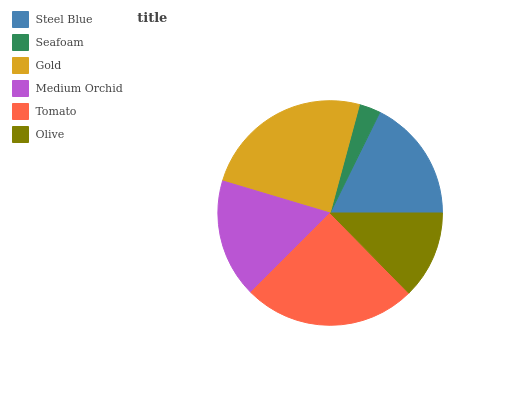Is Seafoam the minimum?
Answer yes or no. Yes. Is Tomato the maximum?
Answer yes or no. Yes. Is Gold the minimum?
Answer yes or no. No. Is Gold the maximum?
Answer yes or no. No. Is Gold greater than Seafoam?
Answer yes or no. Yes. Is Seafoam less than Gold?
Answer yes or no. Yes. Is Seafoam greater than Gold?
Answer yes or no. No. Is Gold less than Seafoam?
Answer yes or no. No. Is Steel Blue the high median?
Answer yes or no. Yes. Is Medium Orchid the low median?
Answer yes or no. Yes. Is Seafoam the high median?
Answer yes or no. No. Is Gold the low median?
Answer yes or no. No. 